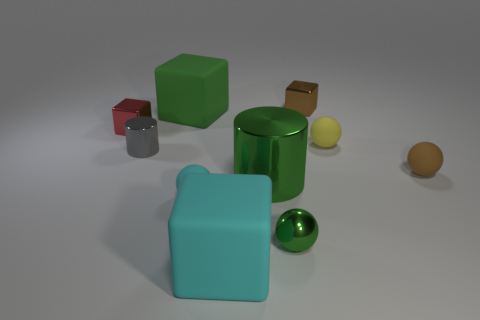Is the large green cylinder made of the same material as the small green cube? The large green cylinder and the small green cube seem to share a similar reflective surface, suggesting they may indeed be made of the same or comparable materials. 